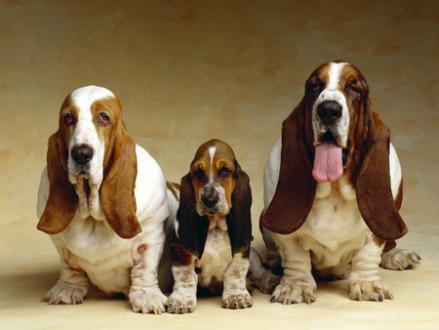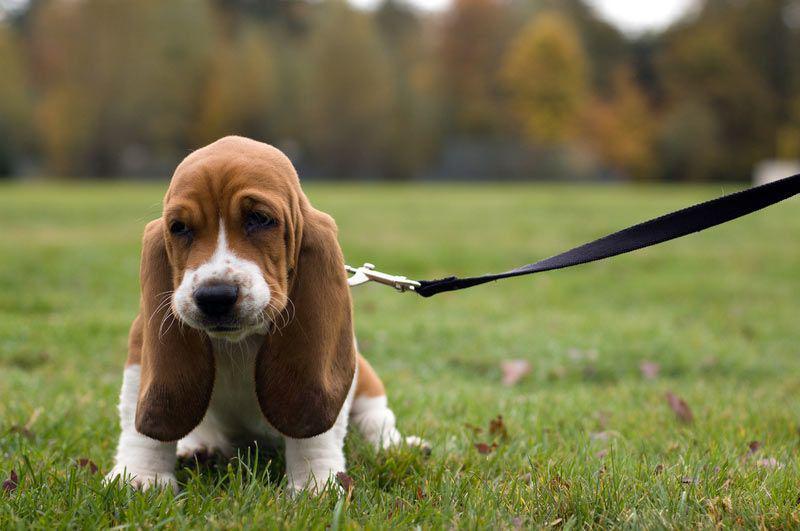The first image is the image on the left, the second image is the image on the right. Given the left and right images, does the statement "The dog in the image on the right is against a white background." hold true? Answer yes or no. No. 